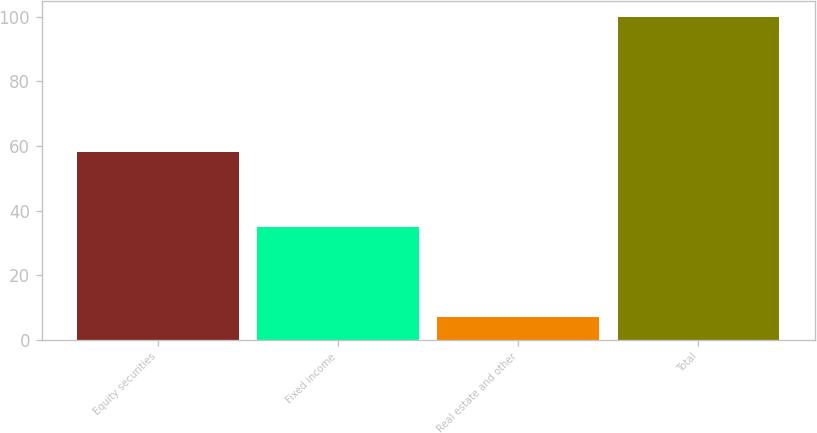<chart> <loc_0><loc_0><loc_500><loc_500><bar_chart><fcel>Equity securities<fcel>Fixed income<fcel>Real estate and other<fcel>Total<nl><fcel>58<fcel>35<fcel>7<fcel>100<nl></chart> 